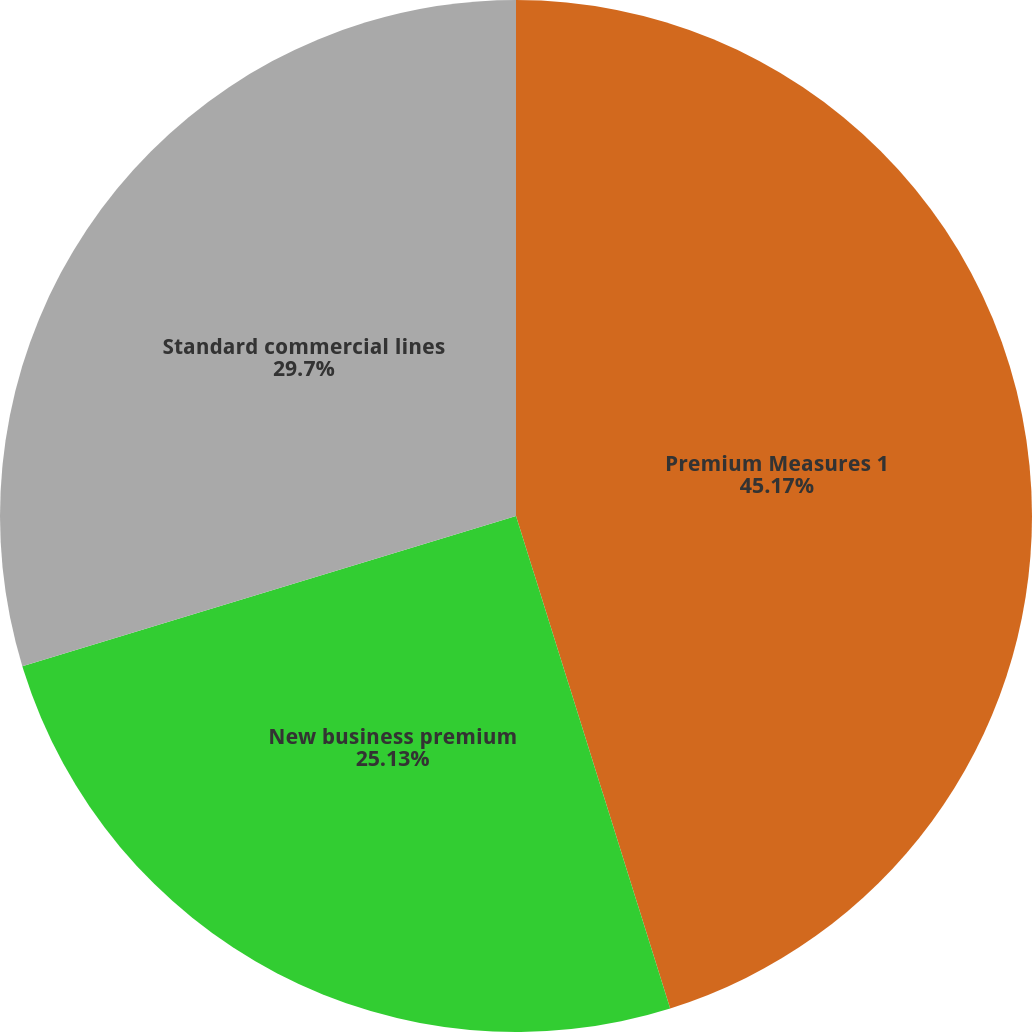Convert chart. <chart><loc_0><loc_0><loc_500><loc_500><pie_chart><fcel>Premium Measures 1<fcel>New business premium<fcel>Standard commercial lines<nl><fcel>45.17%<fcel>25.13%<fcel>29.7%<nl></chart> 